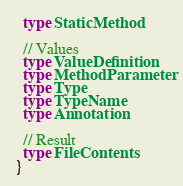Convert code to text. <code><loc_0><loc_0><loc_500><loc_500><_Scala_>  type StaticMethod

  // Values
  type ValueDefinition
  type MethodParameter
  type Type
  type TypeName
  type Annotation

  // Result
  type FileContents
}
</code> 